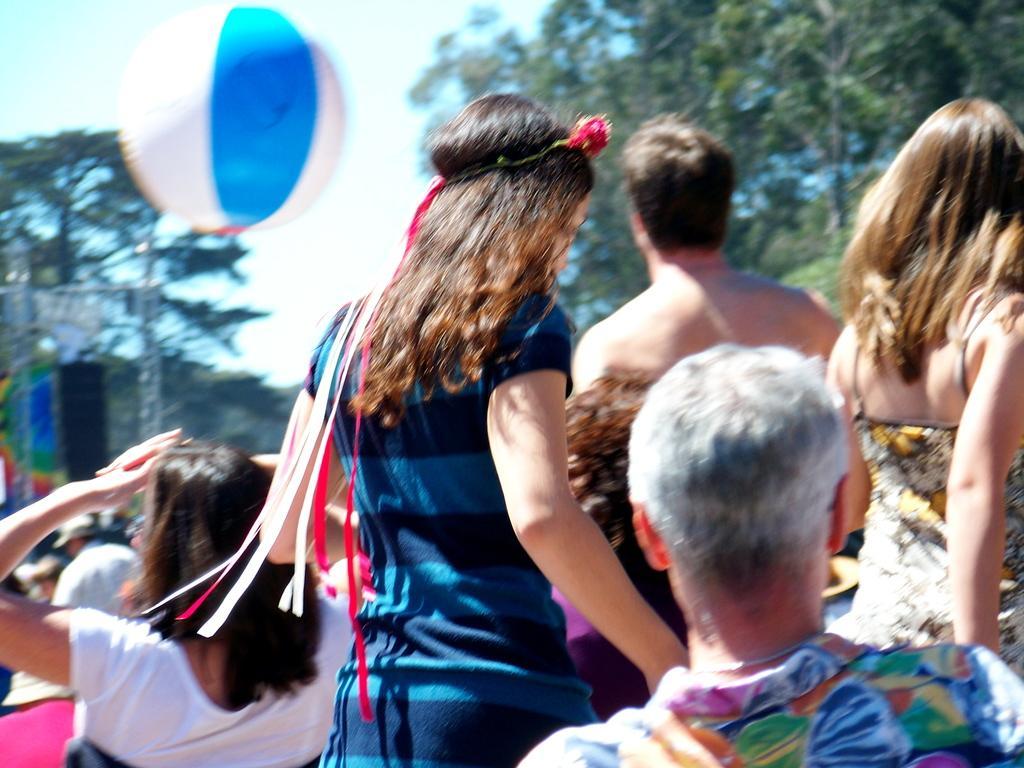Please provide a concise description of this image. In this picture we can see a group of people, balloon, trees, some objects and in the background we can see the sky. 